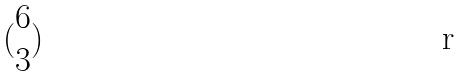Convert formula to latex. <formula><loc_0><loc_0><loc_500><loc_500>( \begin{matrix} 6 \\ 3 \end{matrix} )</formula> 